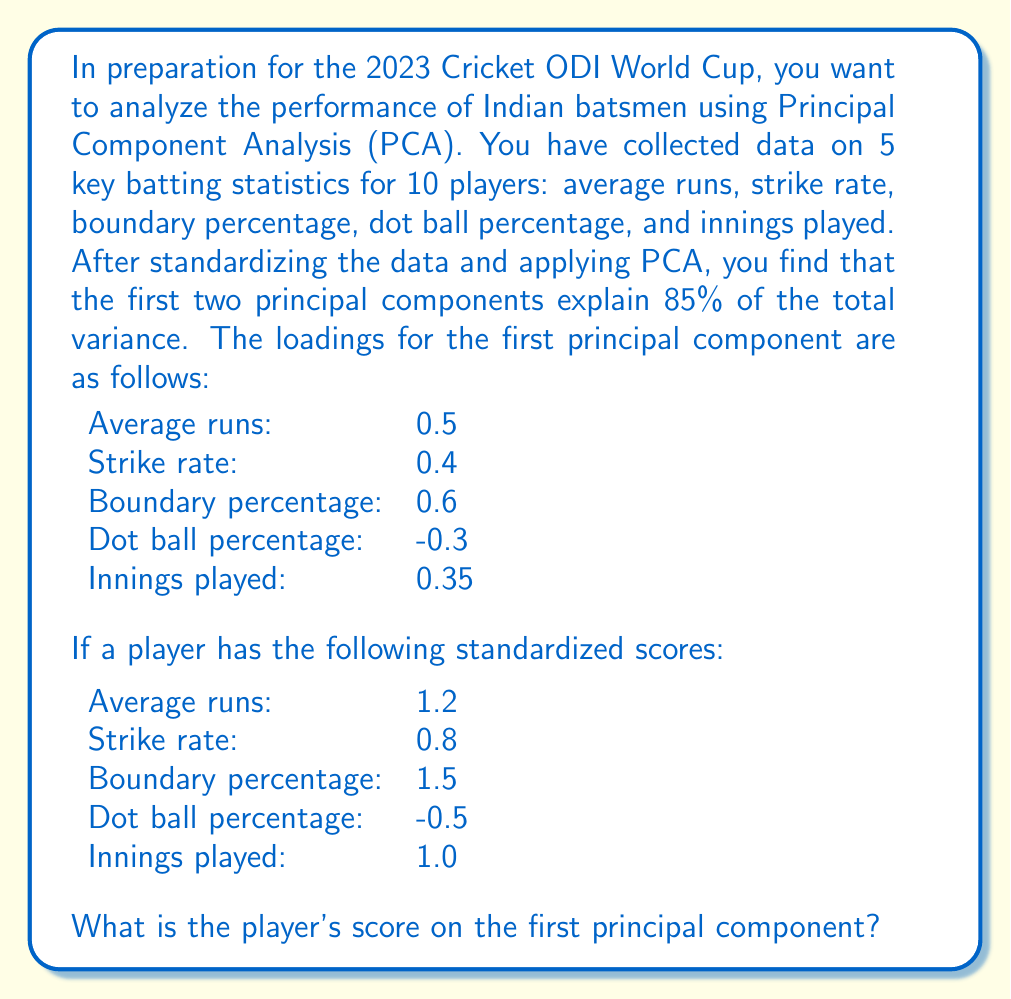Can you solve this math problem? To solve this problem, we need to understand the concept of Principal Component Analysis (PCA) and how to calculate a score using the principal component loadings.

1. Principal Component Analysis (PCA) is a dimensionality reduction technique that transforms a set of correlated variables into a smaller set of uncorrelated variables called principal components.

2. The loadings of a principal component represent the weights of each original variable in that component. They indicate the importance of each variable in defining the component.

3. To calculate a player's score on a principal component, we need to multiply each standardized variable by its corresponding loading and sum the results.

Let's calculate the score step by step:

1. Multiply each standardized score by its corresponding loading:

   Average runs: $1.2 \times 0.5 = 0.6$
   Strike rate: $0.8 \times 0.4 = 0.32$
   Boundary percentage: $1.5 \times 0.6 = 0.9$
   Dot ball percentage: $-0.5 \times (-0.3) = 0.15$
   Innings played: $1.0 \times 0.35 = 0.35$

2. Sum all the products:

   $0.6 + 0.32 + 0.9 + 0.15 + 0.35 = 2.32$

Therefore, the player's score on the first principal component is 2.32.

This score represents the player's overall performance in terms of the first principal component, which captures the most significant patterns in the data. A higher score indicates better overall performance across the measured statistics.
Answer: 2.32 